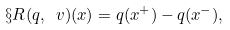Convert formula to latex. <formula><loc_0><loc_0><loc_500><loc_500>\S R ( q , \ v ) ( x ) = q ( x ^ { + } ) - q ( x ^ { - } ) ,</formula> 